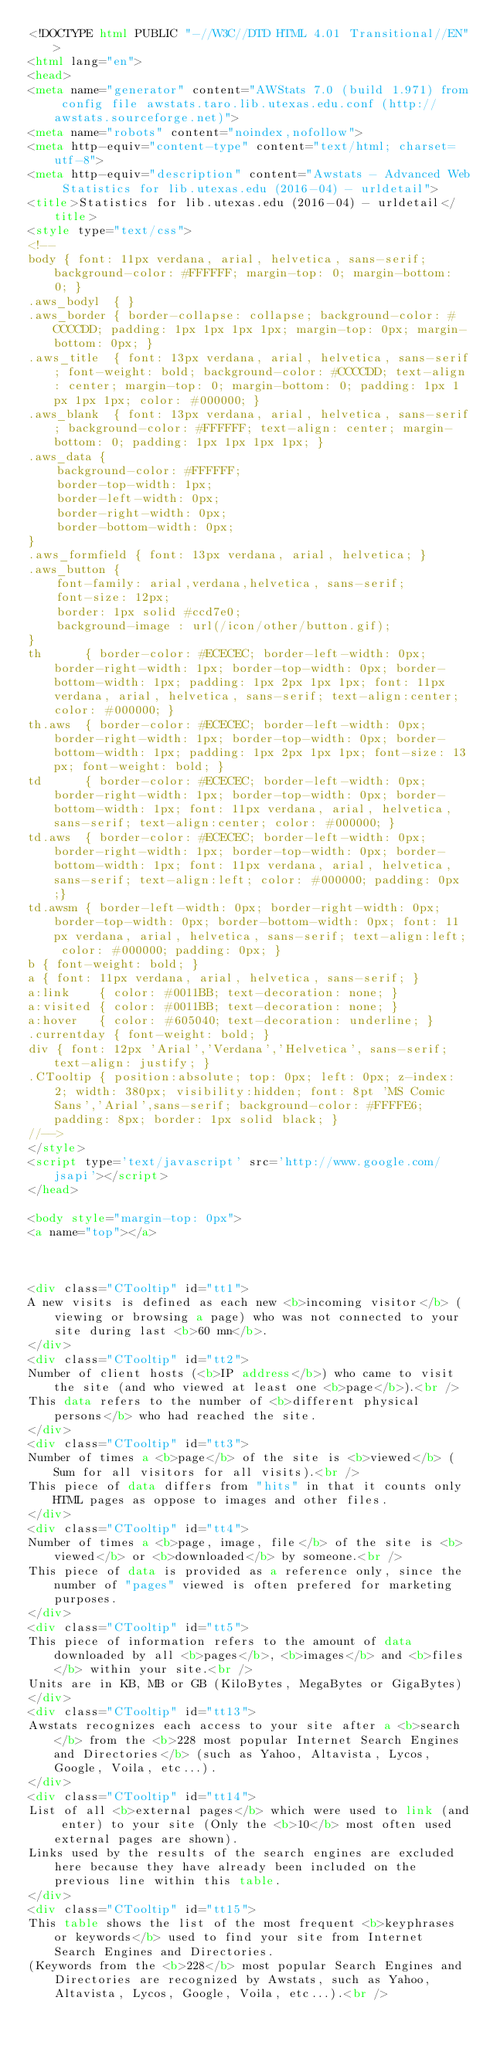Convert code to text. <code><loc_0><loc_0><loc_500><loc_500><_HTML_><!DOCTYPE html PUBLIC "-//W3C//DTD HTML 4.01 Transitional//EN">
<html lang="en">
<head>
<meta name="generator" content="AWStats 7.0 (build 1.971) from config file awstats.taro.lib.utexas.edu.conf (http://awstats.sourceforge.net)">
<meta name="robots" content="noindex,nofollow">
<meta http-equiv="content-type" content="text/html; charset=utf-8">
<meta http-equiv="description" content="Awstats - Advanced Web Statistics for lib.utexas.edu (2016-04) - urldetail">
<title>Statistics for lib.utexas.edu (2016-04) - urldetail</title>
<style type="text/css">
<!--
body { font: 11px verdana, arial, helvetica, sans-serif; background-color: #FFFFFF; margin-top: 0; margin-bottom: 0; }
.aws_bodyl  { }
.aws_border { border-collapse: collapse; background-color: #CCCCDD; padding: 1px 1px 1px 1px; margin-top: 0px; margin-bottom: 0px; }
.aws_title  { font: 13px verdana, arial, helvetica, sans-serif; font-weight: bold; background-color: #CCCCDD; text-align: center; margin-top: 0; margin-bottom: 0; padding: 1px 1px 1px 1px; color: #000000; }
.aws_blank  { font: 13px verdana, arial, helvetica, sans-serif; background-color: #FFFFFF; text-align: center; margin-bottom: 0; padding: 1px 1px 1px 1px; }
.aws_data {
	background-color: #FFFFFF;
	border-top-width: 1px;   
	border-left-width: 0px;  
	border-right-width: 0px; 
	border-bottom-width: 0px;
}
.aws_formfield { font: 13px verdana, arial, helvetica; }
.aws_button {
	font-family: arial,verdana,helvetica, sans-serif;
	font-size: 12px;
	border: 1px solid #ccd7e0;
	background-image : url(/icon/other/button.gif);
}
th		{ border-color: #ECECEC; border-left-width: 0px; border-right-width: 1px; border-top-width: 0px; border-bottom-width: 1px; padding: 1px 2px 1px 1px; font: 11px verdana, arial, helvetica, sans-serif; text-align:center; color: #000000; }
th.aws	{ border-color: #ECECEC; border-left-width: 0px; border-right-width: 1px; border-top-width: 0px; border-bottom-width: 1px; padding: 1px 2px 1px 1px; font-size: 13px; font-weight: bold; }
td		{ border-color: #ECECEC; border-left-width: 0px; border-right-width: 1px; border-top-width: 0px; border-bottom-width: 1px; font: 11px verdana, arial, helvetica, sans-serif; text-align:center; color: #000000; }
td.aws	{ border-color: #ECECEC; border-left-width: 0px; border-right-width: 1px; border-top-width: 0px; border-bottom-width: 1px; font: 11px verdana, arial, helvetica, sans-serif; text-align:left; color: #000000; padding: 0px;}
td.awsm	{ border-left-width: 0px; border-right-width: 0px; border-top-width: 0px; border-bottom-width: 0px; font: 11px verdana, arial, helvetica, sans-serif; text-align:left; color: #000000; padding: 0px; }
b { font-weight: bold; }
a { font: 11px verdana, arial, helvetica, sans-serif; }
a:link    { color: #0011BB; text-decoration: none; }
a:visited { color: #0011BB; text-decoration: none; }
a:hover   { color: #605040; text-decoration: underline; }
.currentday { font-weight: bold; }
div { font: 12px 'Arial','Verdana','Helvetica', sans-serif; text-align: justify; }
.CTooltip { position:absolute; top: 0px; left: 0px; z-index: 2; width: 380px; visibility:hidden; font: 8pt 'MS Comic Sans','Arial',sans-serif; background-color: #FFFFE6; padding: 8px; border: 1px solid black; }
//-->
</style>
<script type='text/javascript' src='http://www.google.com/jsapi'></script>
</head>

<body style="margin-top: 0px">
<a name="top"></a>



<div class="CTooltip" id="tt1">
A new visits is defined as each new <b>incoming visitor</b> (viewing or browsing a page) who was not connected to your site during last <b>60 mn</b>.
</div>
<div class="CTooltip" id="tt2">
Number of client hosts (<b>IP address</b>) who came to visit the site (and who viewed at least one <b>page</b>).<br />
This data refers to the number of <b>different physical persons</b> who had reached the site.
</div>
<div class="CTooltip" id="tt3">
Number of times a <b>page</b> of the site is <b>viewed</b> (Sum for all visitors for all visits).<br />
This piece of data differs from "hits" in that it counts only HTML pages as oppose to images and other files.
</div>
<div class="CTooltip" id="tt4">
Number of times a <b>page, image, file</b> of the site is <b>viewed</b> or <b>downloaded</b> by someone.<br />
This piece of data is provided as a reference only, since the number of "pages" viewed is often prefered for marketing purposes.
</div>
<div class="CTooltip" id="tt5">
This piece of information refers to the amount of data downloaded by all <b>pages</b>, <b>images</b> and <b>files</b> within your site.<br />
Units are in KB, MB or GB (KiloBytes, MegaBytes or GigaBytes)
</div>
<div class="CTooltip" id="tt13">
Awstats recognizes each access to your site after a <b>search</b> from the <b>228 most popular Internet Search Engines and Directories</b> (such as Yahoo, Altavista, Lycos, Google, Voila, etc...).
</div>
<div class="CTooltip" id="tt14">
List of all <b>external pages</b> which were used to link (and enter) to your site (Only the <b>10</b> most often used external pages are shown).
Links used by the results of the search engines are excluded here because they have already been included on the previous line within this table.
</div>
<div class="CTooltip" id="tt15">
This table shows the list of the most frequent <b>keyphrases or keywords</b> used to find your site from Internet Search Engines and Directories.
(Keywords from the <b>228</b> most popular Search Engines and Directories are recognized by Awstats, such as Yahoo, Altavista, Lycos, Google, Voila, etc...).<br /></code> 